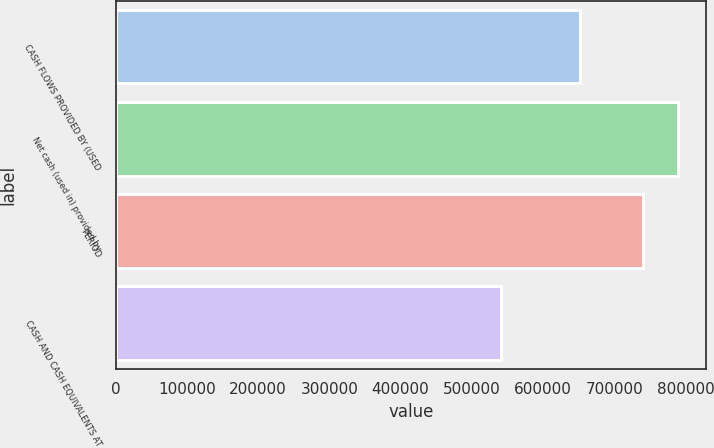Convert chart. <chart><loc_0><loc_0><loc_500><loc_500><bar_chart><fcel>CASH FLOWS PROVIDED BY (USED<fcel>Net cash (used in) provided by<fcel>PERIOD<fcel>CASH AND CASH EQUIVALENTS AT<nl><fcel>651897<fcel>789548<fcel>740884<fcel>540403<nl></chart> 